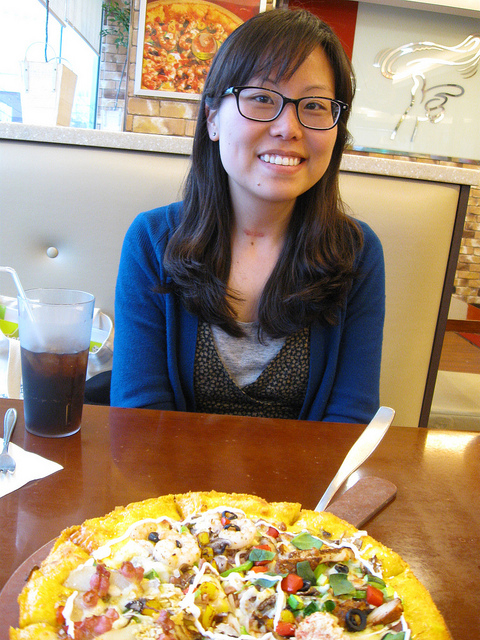How many blue airplanes are in the image? 0 